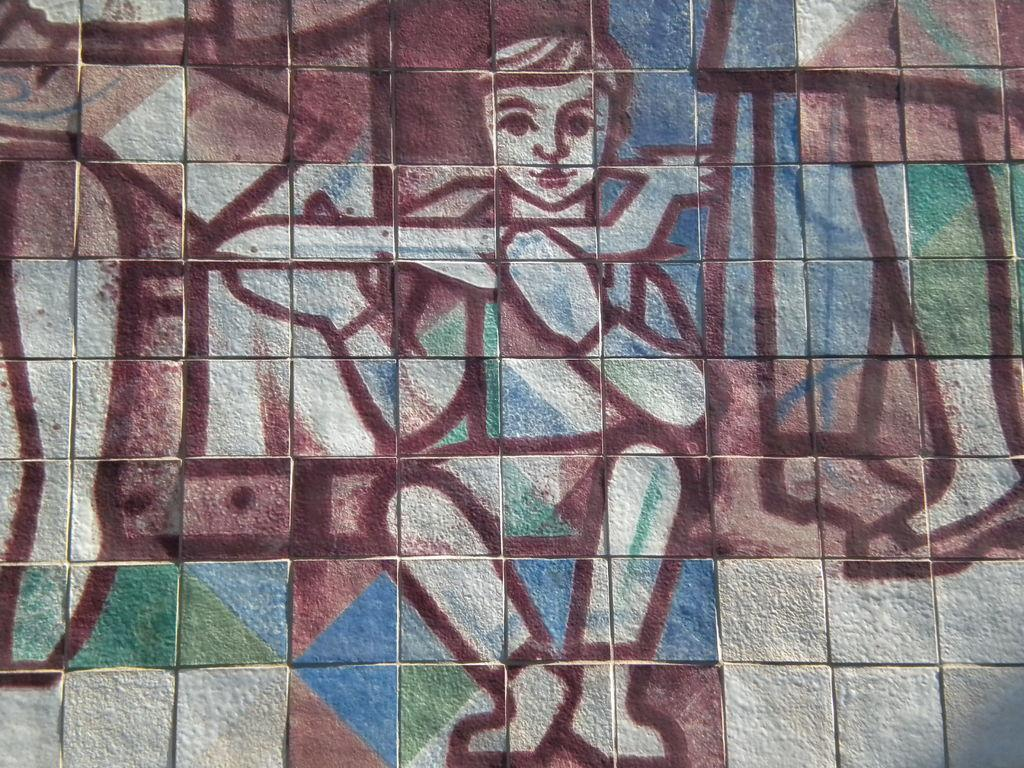What is present in the image? There is a wall in the image. What can be observed on the wall? The wall has some painting on it. How many children are playing near the wall in the image? There are no children present in the image; it only features a wall with some painting on it. What type of root can be seen growing from the wall in the image? There is no root visible in the image; it only shows a wall with some painting on it. 